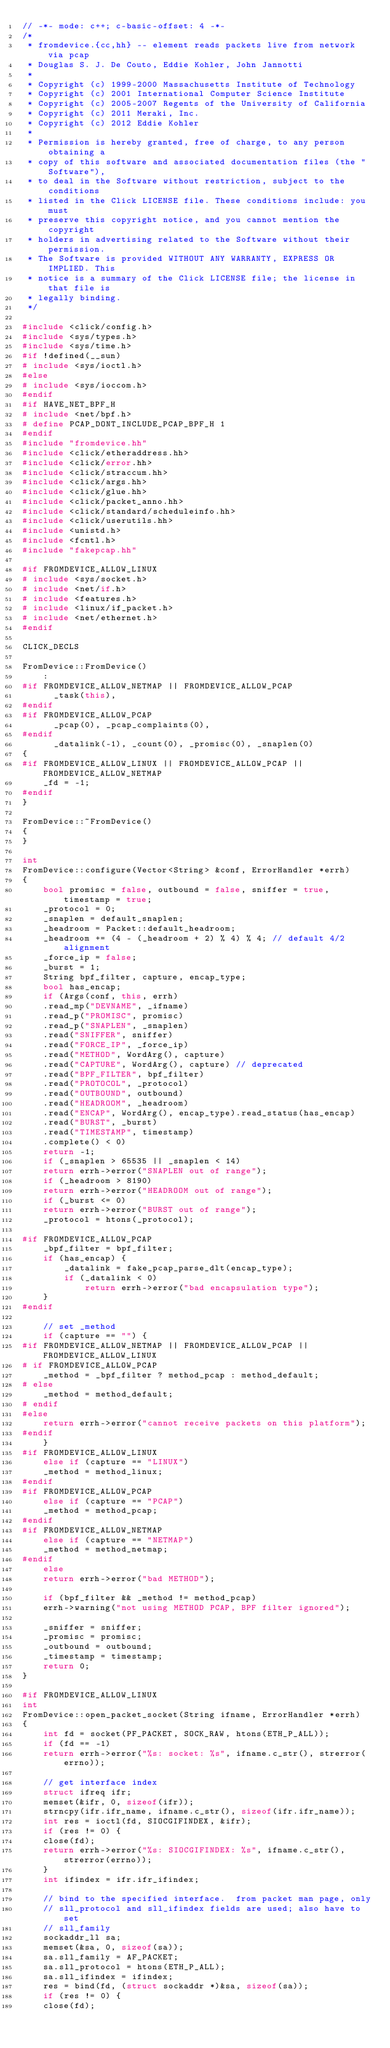<code> <loc_0><loc_0><loc_500><loc_500><_C++_>// -*- mode: c++; c-basic-offset: 4 -*-
/*
 * fromdevice.{cc,hh} -- element reads packets live from network via pcap
 * Douglas S. J. De Couto, Eddie Kohler, John Jannotti
 *
 * Copyright (c) 1999-2000 Massachusetts Institute of Technology
 * Copyright (c) 2001 International Computer Science Institute
 * Copyright (c) 2005-2007 Regents of the University of California
 * Copyright (c) 2011 Meraki, Inc.
 * Copyright (c) 2012 Eddie Kohler
 *
 * Permission is hereby granted, free of charge, to any person obtaining a
 * copy of this software and associated documentation files (the "Software"),
 * to deal in the Software without restriction, subject to the conditions
 * listed in the Click LICENSE file. These conditions include: you must
 * preserve this copyright notice, and you cannot mention the copyright
 * holders in advertising related to the Software without their permission.
 * The Software is provided WITHOUT ANY WARRANTY, EXPRESS OR IMPLIED. This
 * notice is a summary of the Click LICENSE file; the license in that file is
 * legally binding.
 */

#include <click/config.h>
#include <sys/types.h>
#include <sys/time.h>
#if !defined(__sun)
# include <sys/ioctl.h>
#else
# include <sys/ioccom.h>
#endif
#if HAVE_NET_BPF_H
# include <net/bpf.h>
# define PCAP_DONT_INCLUDE_PCAP_BPF_H 1
#endif
#include "fromdevice.hh"
#include <click/etheraddress.hh>
#include <click/error.hh>
#include <click/straccum.hh>
#include <click/args.hh>
#include <click/glue.hh>
#include <click/packet_anno.hh>
#include <click/standard/scheduleinfo.hh>
#include <click/userutils.hh>
#include <unistd.h>
#include <fcntl.h>
#include "fakepcap.hh"

#if FROMDEVICE_ALLOW_LINUX
# include <sys/socket.h>
# include <net/if.h>
# include <features.h>
# include <linux/if_packet.h>
# include <net/ethernet.h>
#endif

CLICK_DECLS

FromDevice::FromDevice()
    :
#if FROMDEVICE_ALLOW_NETMAP || FROMDEVICE_ALLOW_PCAP
      _task(this),
#endif
#if FROMDEVICE_ALLOW_PCAP
      _pcap(0), _pcap_complaints(0),
#endif
      _datalink(-1), _count(0), _promisc(0), _snaplen(0)
{
#if FROMDEVICE_ALLOW_LINUX || FROMDEVICE_ALLOW_PCAP || FROMDEVICE_ALLOW_NETMAP
    _fd = -1;
#endif
}

FromDevice::~FromDevice()
{
}

int
FromDevice::configure(Vector<String> &conf, ErrorHandler *errh)
{
    bool promisc = false, outbound = false, sniffer = true, timestamp = true;
    _protocol = 0;
    _snaplen = default_snaplen;
    _headroom = Packet::default_headroom;
    _headroom += (4 - (_headroom + 2) % 4) % 4; // default 4/2 alignment
    _force_ip = false;
    _burst = 1;
    String bpf_filter, capture, encap_type;
    bool has_encap;
    if (Args(conf, this, errh)
	.read_mp("DEVNAME", _ifname)
	.read_p("PROMISC", promisc)
	.read_p("SNAPLEN", _snaplen)
	.read("SNIFFER", sniffer)
	.read("FORCE_IP", _force_ip)
	.read("METHOD", WordArg(), capture)
	.read("CAPTURE", WordArg(), capture) // deprecated
	.read("BPF_FILTER", bpf_filter)
	.read("PROTOCOL", _protocol)
	.read("OUTBOUND", outbound)
	.read("HEADROOM", _headroom)
	.read("ENCAP", WordArg(), encap_type).read_status(has_encap)
	.read("BURST", _burst)
	.read("TIMESTAMP", timestamp)
	.complete() < 0)
	return -1;
    if (_snaplen > 65535 || _snaplen < 14)
	return errh->error("SNAPLEN out of range");
    if (_headroom > 8190)
	return errh->error("HEADROOM out of range");
    if (_burst <= 0)
	return errh->error("BURST out of range");
    _protocol = htons(_protocol);

#if FROMDEVICE_ALLOW_PCAP
    _bpf_filter = bpf_filter;
    if (has_encap) {
        _datalink = fake_pcap_parse_dlt(encap_type);
        if (_datalink < 0)
            return errh->error("bad encapsulation type");
    }
#endif

    // set _method
    if (capture == "") {
#if FROMDEVICE_ALLOW_NETMAP || FROMDEVICE_ALLOW_PCAP || FROMDEVICE_ALLOW_LINUX
# if FROMDEVICE_ALLOW_PCAP
	_method = _bpf_filter ? method_pcap : method_default;
# else
	_method = method_default;
# endif
#else
	return errh->error("cannot receive packets on this platform");
#endif
    }
#if FROMDEVICE_ALLOW_LINUX
    else if (capture == "LINUX")
	_method = method_linux;
#endif
#if FROMDEVICE_ALLOW_PCAP
    else if (capture == "PCAP")
	_method = method_pcap;
#endif
#if FROMDEVICE_ALLOW_NETMAP
    else if (capture == "NETMAP")
	_method = method_netmap;
#endif
    else
	return errh->error("bad METHOD");

    if (bpf_filter && _method != method_pcap)
	errh->warning("not using METHOD PCAP, BPF filter ignored");

    _sniffer = sniffer;
    _promisc = promisc;
    _outbound = outbound;
    _timestamp = timestamp;
    return 0;
}

#if FROMDEVICE_ALLOW_LINUX
int
FromDevice::open_packet_socket(String ifname, ErrorHandler *errh)
{
    int fd = socket(PF_PACKET, SOCK_RAW, htons(ETH_P_ALL));
    if (fd == -1)
	return errh->error("%s: socket: %s", ifname.c_str(), strerror(errno));

    // get interface index
    struct ifreq ifr;
    memset(&ifr, 0, sizeof(ifr));
    strncpy(ifr.ifr_name, ifname.c_str(), sizeof(ifr.ifr_name));
    int res = ioctl(fd, SIOCGIFINDEX, &ifr);
    if (res != 0) {
	close(fd);
	return errh->error("%s: SIOCGIFINDEX: %s", ifname.c_str(), strerror(errno));
    }
    int ifindex = ifr.ifr_ifindex;

    // bind to the specified interface.  from packet man page, only
    // sll_protocol and sll_ifindex fields are used; also have to set
    // sll_family
    sockaddr_ll sa;
    memset(&sa, 0, sizeof(sa));
    sa.sll_family = AF_PACKET;
    sa.sll_protocol = htons(ETH_P_ALL);
    sa.sll_ifindex = ifindex;
    res = bind(fd, (struct sockaddr *)&sa, sizeof(sa));
    if (res != 0) {
	close(fd);</code> 